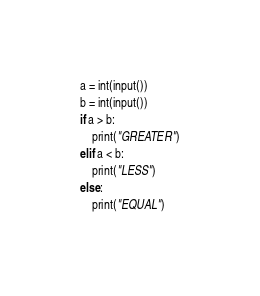Convert code to text. <code><loc_0><loc_0><loc_500><loc_500><_Python_>a = int(input())
b = int(input())
if a > b:
    print("GREATER")
elif a < b:
    print("LESS")
else:
    print("EQUAL")
</code> 